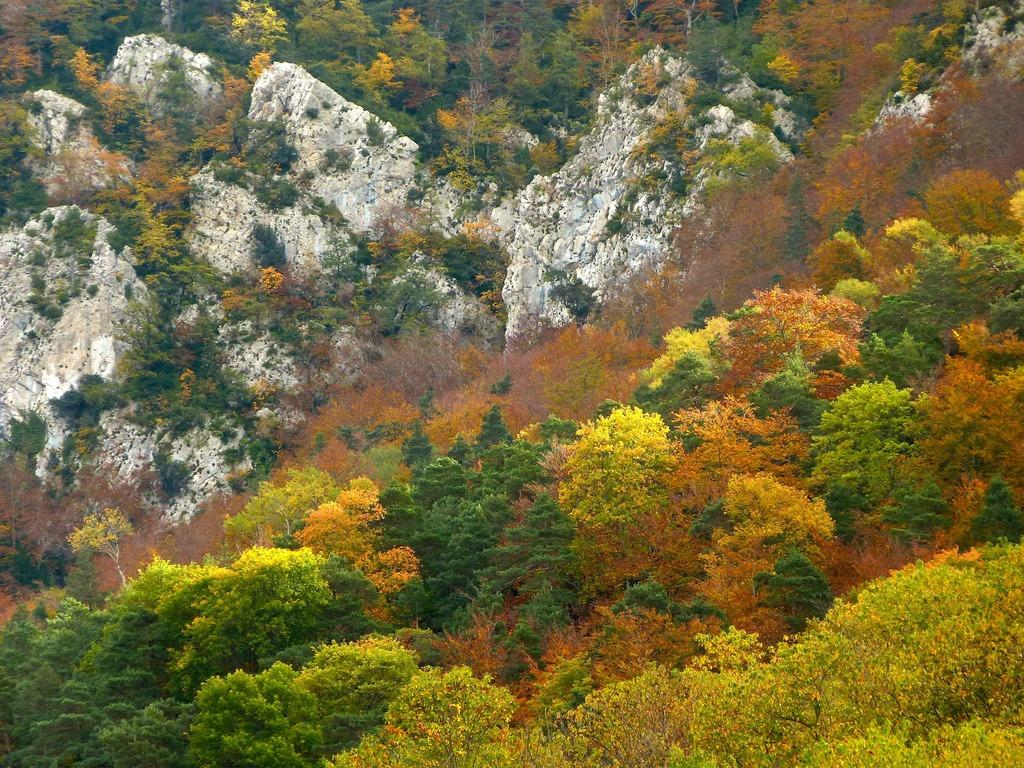What type of vegetation can be seen in the image? There are trees in the image. What colors are the trees displaying? The trees have green, yellow, and orange colors. What other elements can be seen in the background of the image? There are rocks visible in the background of the image. What time does the clock show in the image? There is no clock present in the image, so it is not possible to determine the time. 